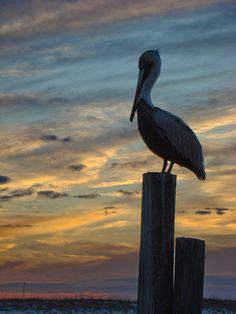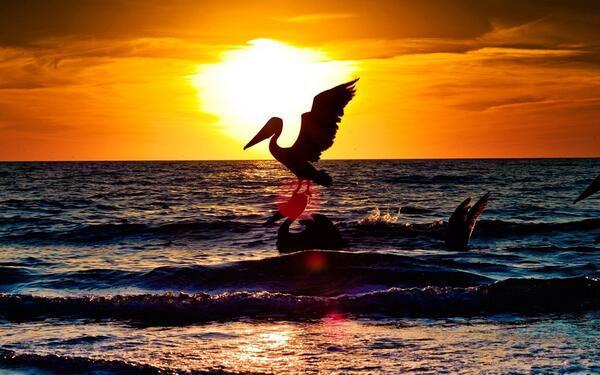The first image is the image on the left, the second image is the image on the right. Given the left and right images, does the statement "An image shows a pelican perched on a tall post next to a shorter post, in front of a sky with no birds flying across it." hold true? Answer yes or no. Yes. The first image is the image on the left, the second image is the image on the right. Examine the images to the left and right. Is the description "A pelican perches on a pole in the image on the left." accurate? Answer yes or no. Yes. 